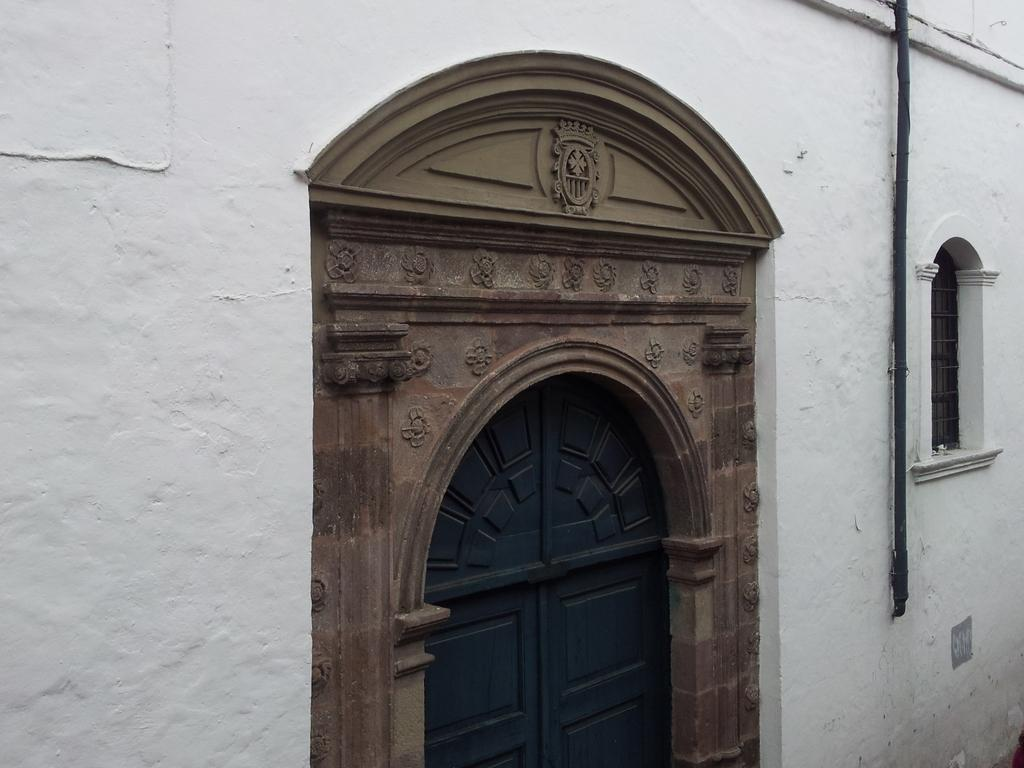What is a prominent feature of the wall in the image? There is a door in the wall. Is there any decoration or design around the door? Yes, there is a design around the door. What other objects are attached to the wall in the image? There is a pipe and a window attached to the wall. What type of authority figure can be seen standing near the wall in the image? There is no authority figure present in the image. Is it raining in the image? The provided facts do not mention any weather conditions, so we cannot determine if it is raining in the image. 